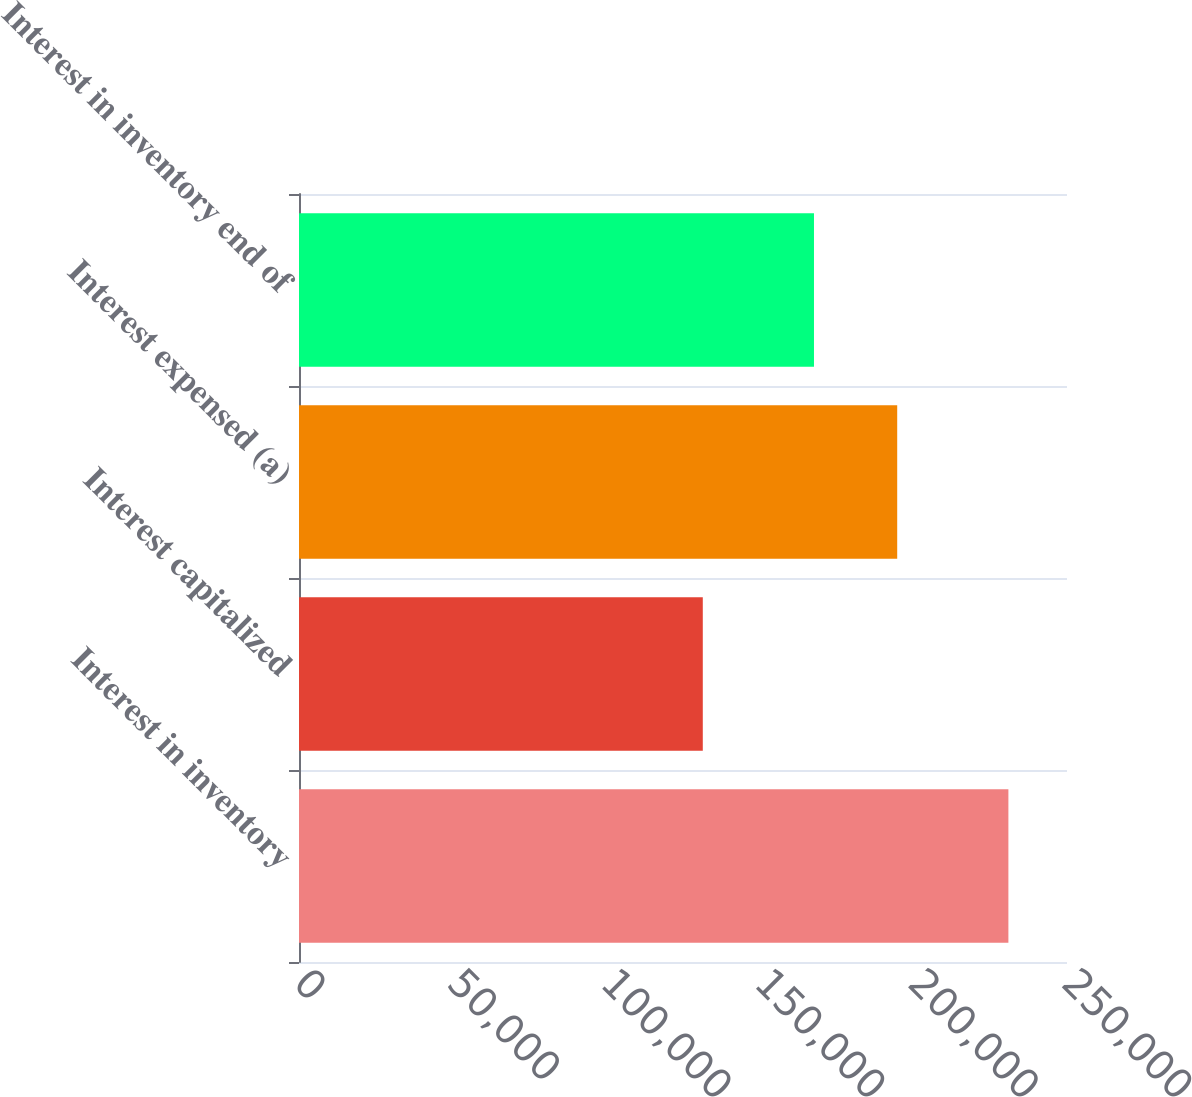Convert chart. <chart><loc_0><loc_0><loc_500><loc_500><bar_chart><fcel>Interest in inventory<fcel>Interest capitalized<fcel>Interest expensed (a)<fcel>Interest in inventory end of<nl><fcel>230922<fcel>131444<fcel>194728<fcel>167638<nl></chart> 